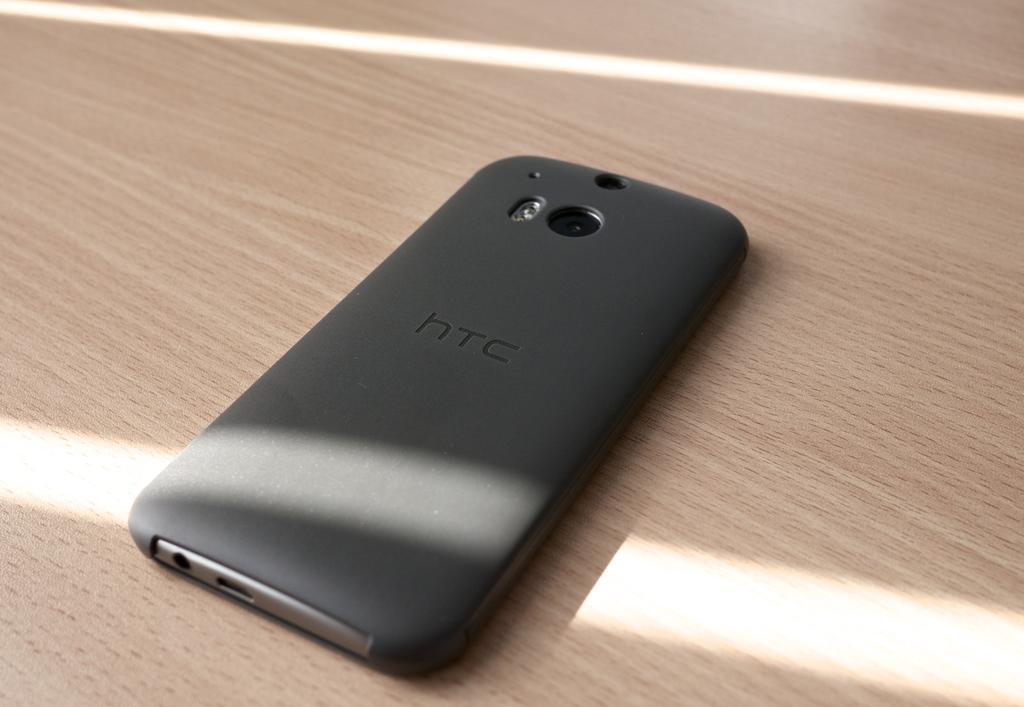<image>
Provide a brief description of the given image. Back of a black HTC cellphone on a wooden table. 